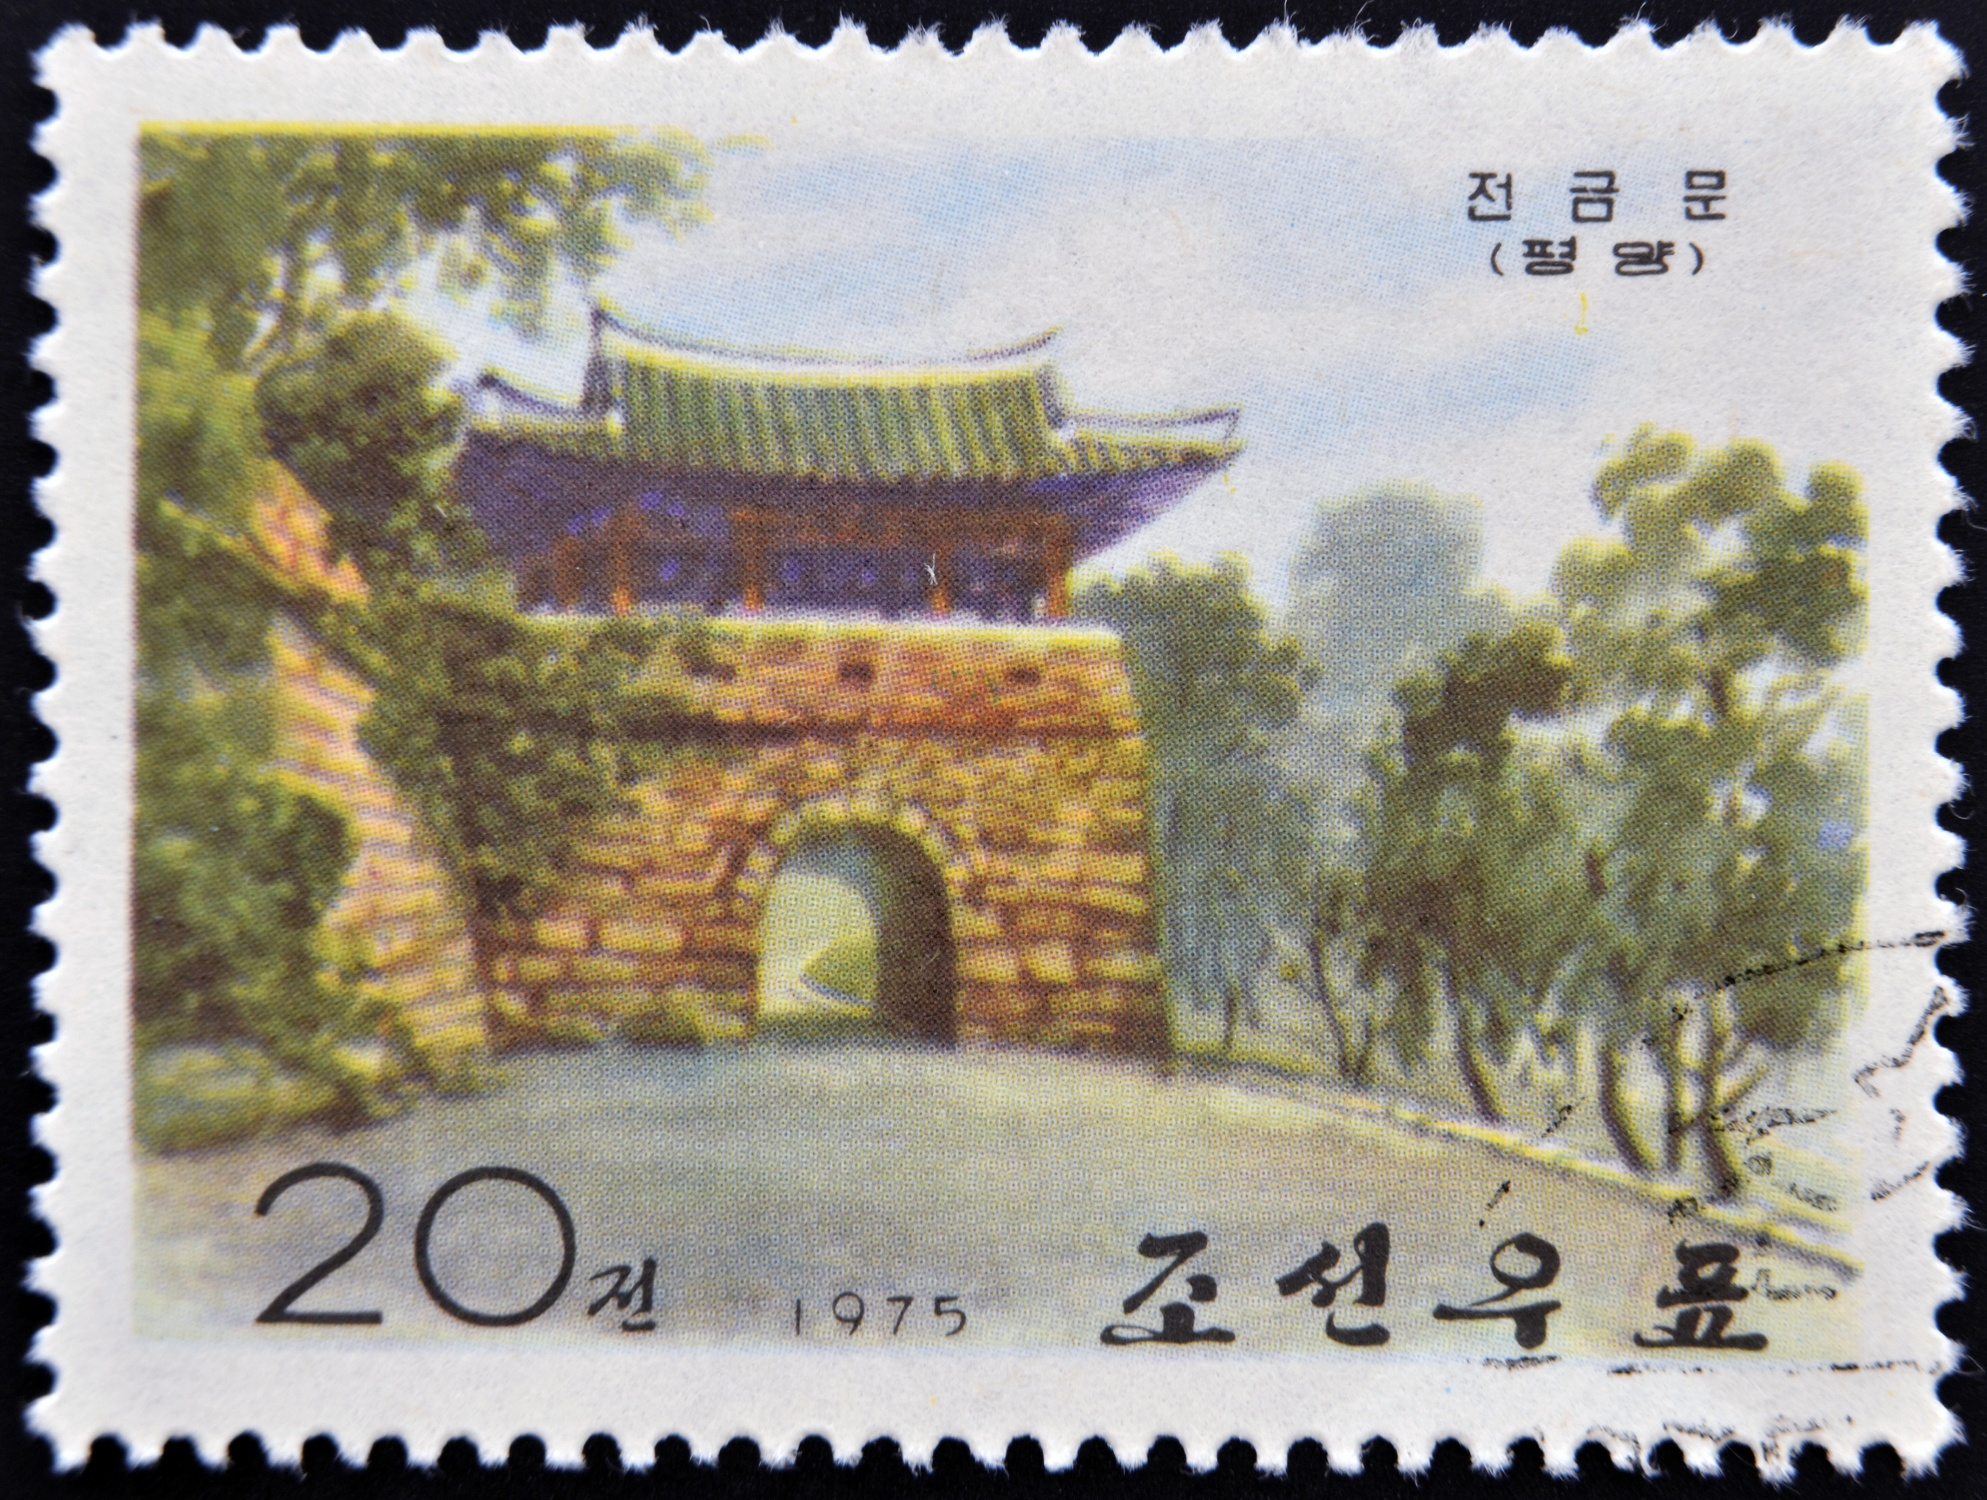If the gate could tell a story, what would it say about the people and the time it was built? If the gate could tell a story, it would speak of an era where craftsmanship and respect for nature were paramount. It would recount the diligent hands of the artisans who meticulously laid each brick and shaped the upturned eaves, blending aesthetics with structural integrity. The gate would tell tales of the hustle and bustle of daily life where it stood guard, witnessing countless passersby – from noblemen in traditional hanboks to common folk. It would reveal snippets of historical events, celebrations, and perhaps even tumultuous periods, standing resilient through it all. The gate would pridefully share the cultural reverence Koreans had for architectural harmony with the natural landscape. Above all, it would narrate the enduring spirit of a people who strived to preserve their heritage and cultural identity amidst an ever-changing world.  Create a fictional story involving a hidden treasure behind the gate. Once upon a time, in the heart of a lush and ancient forest, stood the majestic Korean gate. Legends whispered among the villagers spoke of a hidden treasure buried behind the stone structure, hidden by a wise and benevolent king centuries ago. The treasure was said to hold precious jewels and scrolls containing the wisdom of the ages. One day, a curious young historian named Mira decided to uncover the truth. Guided by an old, cryptic map and her vast knowledge of ancient Korean culture, she embarked on a quest. As she neared the gate, the tranquil garden seemed to come alive, the trees rustling as though cheering her on. Mira carefully examined the bricks and found a small, weathered stone that looked out of place. With a gentle push, the stone gave way to reveal a hidden compartment. Inside, she found a golden key glimmering in the sunlight. Following the map's clues, the key led her to a secret passage behind the gate, where an ancient chest lay untouched. Upon opening it, Mira was awestruck by the shimmering jewels and intricately decorated scrolls. These scrolls held forgotten knowledge of astronomy, medicine, and poetry from a bygone era, proving the legend true. Mira's discovery brought her village great honor, and she dedicated her life to preserving and sharing the newfound wisdom with the world. The gate, now known as the Gate of Knowledge, became a symbol of the enduring quest for learning and the treasures of history.  Based on the image, hypothesize why this specific gate might have been chosen to be featured on a stamp in 1975. This specific gate was likely chosen to be featured on a stamp in 1975 due to its historical and cultural significance. 1975 might have marked an anniversary or a significant event related to the gate or the region where it is located. Featuring such landmarks helps promote national pride and cultural heritage. The gate could be representative of traditional Korean architecture, and placing it on a stamp serves as a reminder of the country's rich history and artistic achievements. Stamps are often used to educate and commemorate, making them ideal for showcasing significant historical structures. Additionally, the gate might have had a symbolic meaning, such as resilience, tradition, or the cultural values of harmony with nature, all important themes to highlight during that period. 